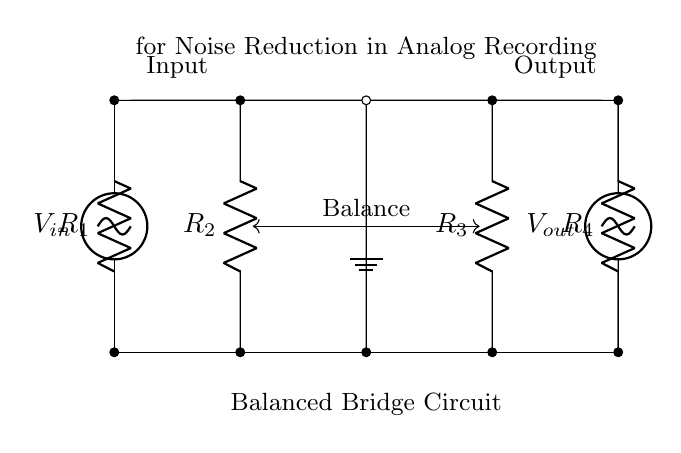What is the input voltage labeled as in the circuit? The input voltage is labeled as V_in, which is indicated on the left side of the circuit diagram.
Answer: V_in What are the resistor values in the bridge circuit? The circuit diagram does not specify numerical values for the resistors R1, R2, R3, and R4, but they are labeled generically as R1, R2, R3, and R4.
Answer: R1, R2, R3, R4 How many resistors are in the balanced bridge circuit? There are four resistors in the bridge circuit, which are labeled as R1, R2, R3, and R4.
Answer: Four What is the purpose of the ground in this circuit? The ground node provides a reference point for the potential in the circuit, allowing for proper functioning of the balanced bridge circuit for noise reduction.
Answer: Reference point Why is balance indicated in the circuit diagram? Balance is crucial in a bridge circuit to minimize the impact of noise and ensure accurate measurements; it is indicated by an arrow labeling the connection between R2 and R3.
Answer: Minimize noise What does R4 represent in this circuit? R4 is one of the resistors in the bridge circuit and contributes to the balancing process; it is labeled as R4 on the right side of the circuit diagram.
Answer: One of the resistors 